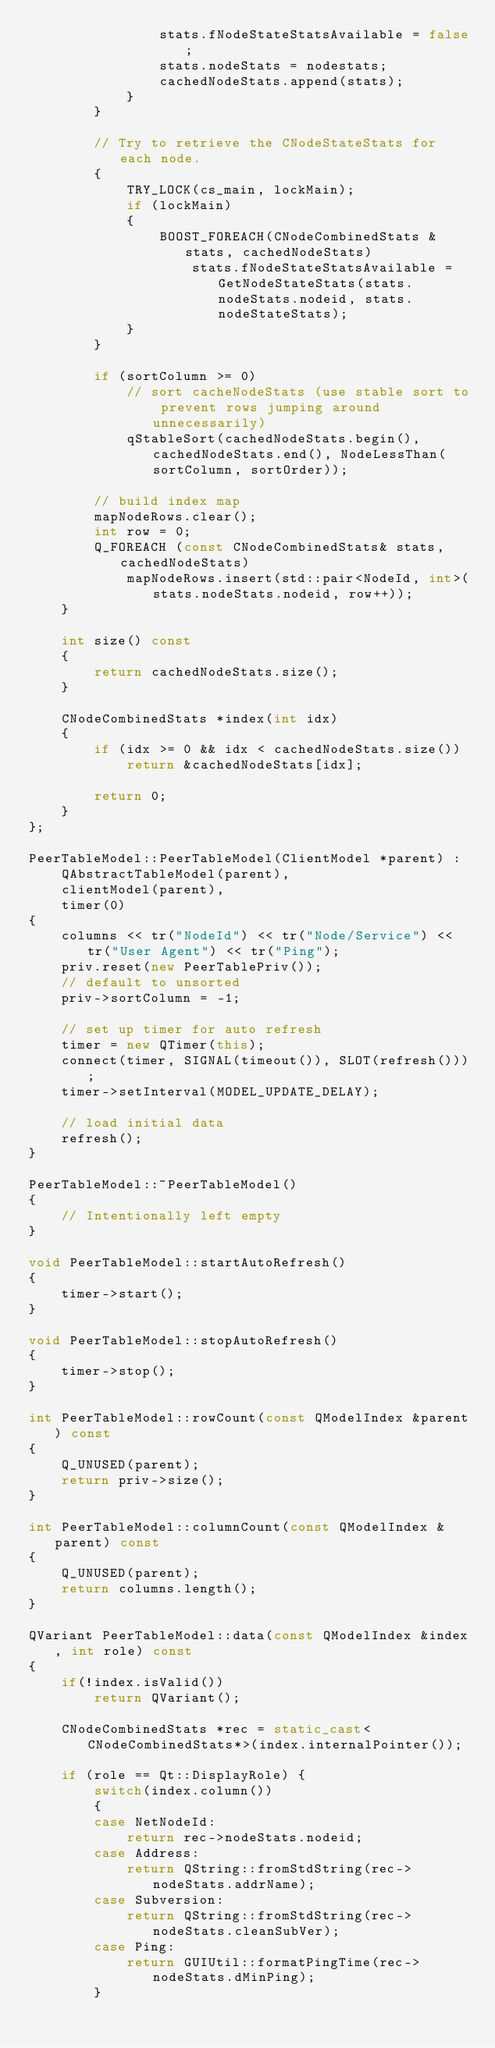<code> <loc_0><loc_0><loc_500><loc_500><_C++_>                stats.fNodeStateStatsAvailable = false;
                stats.nodeStats = nodestats;
                cachedNodeStats.append(stats);
            }
        }

        // Try to retrieve the CNodeStateStats for each node.
        {
            TRY_LOCK(cs_main, lockMain);
            if (lockMain)
            {
                BOOST_FOREACH(CNodeCombinedStats &stats, cachedNodeStats)
                    stats.fNodeStateStatsAvailable = GetNodeStateStats(stats.nodeStats.nodeid, stats.nodeStateStats);
            }
        }

        if (sortColumn >= 0)
            // sort cacheNodeStats (use stable sort to prevent rows jumping around unnecessarily)
            qStableSort(cachedNodeStats.begin(), cachedNodeStats.end(), NodeLessThan(sortColumn, sortOrder));

        // build index map
        mapNodeRows.clear();
        int row = 0;
        Q_FOREACH (const CNodeCombinedStats& stats, cachedNodeStats)
            mapNodeRows.insert(std::pair<NodeId, int>(stats.nodeStats.nodeid, row++));
    }

    int size() const
    {
        return cachedNodeStats.size();
    }

    CNodeCombinedStats *index(int idx)
    {
        if (idx >= 0 && idx < cachedNodeStats.size())
            return &cachedNodeStats[idx];

        return 0;
    }
};

PeerTableModel::PeerTableModel(ClientModel *parent) :
    QAbstractTableModel(parent),
    clientModel(parent),
    timer(0)
{
    columns << tr("NodeId") << tr("Node/Service") << tr("User Agent") << tr("Ping");
    priv.reset(new PeerTablePriv());
    // default to unsorted
    priv->sortColumn = -1;

    // set up timer for auto refresh
    timer = new QTimer(this);
    connect(timer, SIGNAL(timeout()), SLOT(refresh()));
    timer->setInterval(MODEL_UPDATE_DELAY);

    // load initial data
    refresh();
}

PeerTableModel::~PeerTableModel()
{
    // Intentionally left empty
}

void PeerTableModel::startAutoRefresh()
{
    timer->start();
}

void PeerTableModel::stopAutoRefresh()
{
    timer->stop();
}

int PeerTableModel::rowCount(const QModelIndex &parent) const
{
    Q_UNUSED(parent);
    return priv->size();
}

int PeerTableModel::columnCount(const QModelIndex &parent) const
{
    Q_UNUSED(parent);
    return columns.length();
}

QVariant PeerTableModel::data(const QModelIndex &index, int role) const
{
    if(!index.isValid())
        return QVariant();

    CNodeCombinedStats *rec = static_cast<CNodeCombinedStats*>(index.internalPointer());

    if (role == Qt::DisplayRole) {
        switch(index.column())
        {
        case NetNodeId:
            return rec->nodeStats.nodeid;
        case Address:
            return QString::fromStdString(rec->nodeStats.addrName);
        case Subversion:
            return QString::fromStdString(rec->nodeStats.cleanSubVer);
        case Ping:
            return GUIUtil::formatPingTime(rec->nodeStats.dMinPing);
        }</code> 